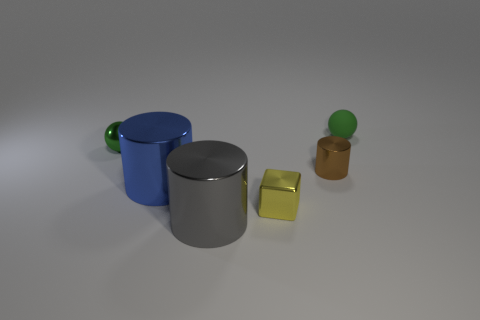Is there anything else that is the same shape as the big blue thing?
Provide a succinct answer. Yes. Is there anything else that has the same size as the brown metallic cylinder?
Give a very brief answer. Yes. What color is the block that is the same material as the gray object?
Keep it short and to the point. Yellow. What is the color of the tiny sphere that is left of the tiny yellow cube?
Make the answer very short. Green. What number of small metal things have the same color as the small cylinder?
Make the answer very short. 0. Are there fewer small brown things in front of the yellow shiny cube than tiny things right of the metallic sphere?
Offer a very short reply. Yes. There is a shiny ball; what number of green spheres are on the left side of it?
Offer a very short reply. 0. Is there a yellow sphere that has the same material as the blue cylinder?
Offer a very short reply. No. Is the number of small shiny things that are behind the big blue shiny object greater than the number of tiny brown metallic cylinders behind the green metal ball?
Offer a terse response. Yes. The block has what size?
Your answer should be very brief. Small. 